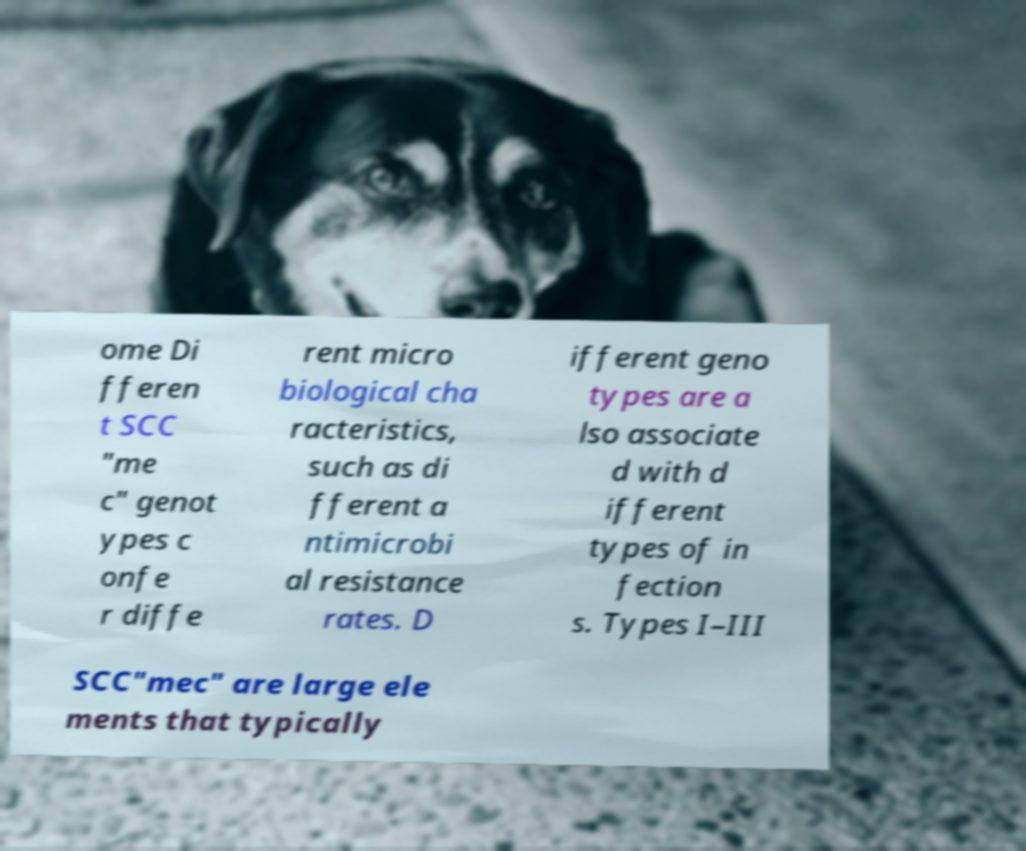I need the written content from this picture converted into text. Can you do that? ome Di fferen t SCC "me c" genot ypes c onfe r diffe rent micro biological cha racteristics, such as di fferent a ntimicrobi al resistance rates. D ifferent geno types are a lso associate d with d ifferent types of in fection s. Types I–III SCC"mec" are large ele ments that typically 